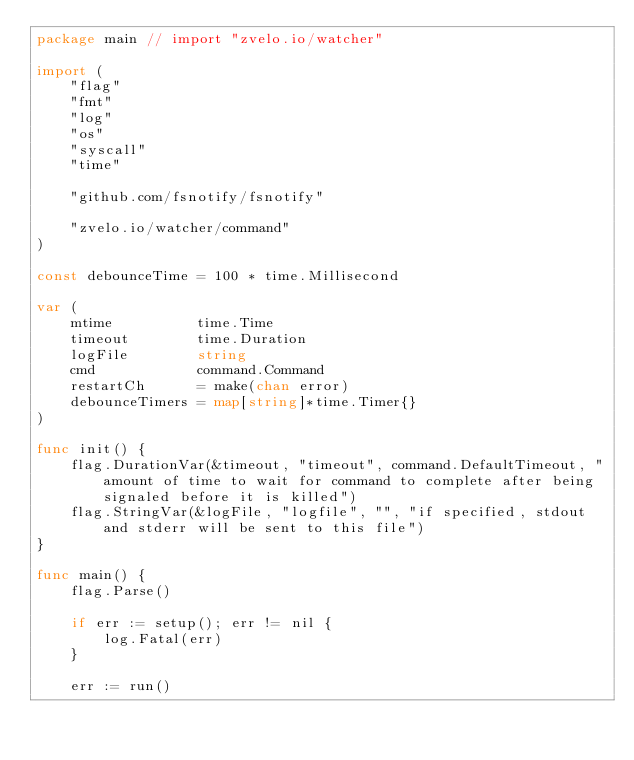Convert code to text. <code><loc_0><loc_0><loc_500><loc_500><_Go_>package main // import "zvelo.io/watcher"

import (
	"flag"
	"fmt"
	"log"
	"os"
	"syscall"
	"time"

	"github.com/fsnotify/fsnotify"

	"zvelo.io/watcher/command"
)

const debounceTime = 100 * time.Millisecond

var (
	mtime          time.Time
	timeout        time.Duration
	logFile        string
	cmd            command.Command
	restartCh      = make(chan error)
	debounceTimers = map[string]*time.Timer{}
)

func init() {
	flag.DurationVar(&timeout, "timeout", command.DefaultTimeout, "amount of time to wait for command to complete after being signaled before it is killed")
	flag.StringVar(&logFile, "logfile", "", "if specified, stdout and stderr will be sent to this file")
}

func main() {
	flag.Parse()

	if err := setup(); err != nil {
		log.Fatal(err)
	}

	err := run()
</code> 